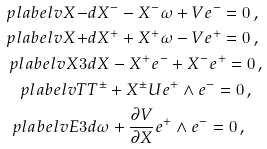Convert formula to latex. <formula><loc_0><loc_0><loc_500><loc_500>\ p l a b e l { v X - } & d X ^ { - } - X ^ { - } \omega + V e ^ { - } = 0 \, , \\ \ p l a b e l { v X + } & d X ^ { + } + X ^ { + } \omega - V e ^ { + } = 0 \, , \\ \ p l a b e l { v X 3 } & d X - X ^ { + } e ^ { - } + X ^ { - } e ^ { + } = 0 \, , \\ \ p l a b e l { v T } & T ^ { \pm } + X ^ { \pm } U e ^ { + } \wedge e ^ { - } = 0 \, , \\ \ p l a b e l { v E 3 } & d \omega + \frac { \partial V } { \partial X } e ^ { + } \wedge e ^ { - } = 0 \, ,</formula> 